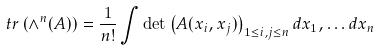Convert formula to latex. <formula><loc_0><loc_0><loc_500><loc_500>\ t r \left ( \wedge ^ { n } ( A ) \right ) = \frac { 1 } { n ! } \int \det \left ( A ( x _ { i } , x _ { j } ) \right ) _ { 1 \leq i , j \leq n } d x _ { 1 } , \dots d x _ { n }</formula> 